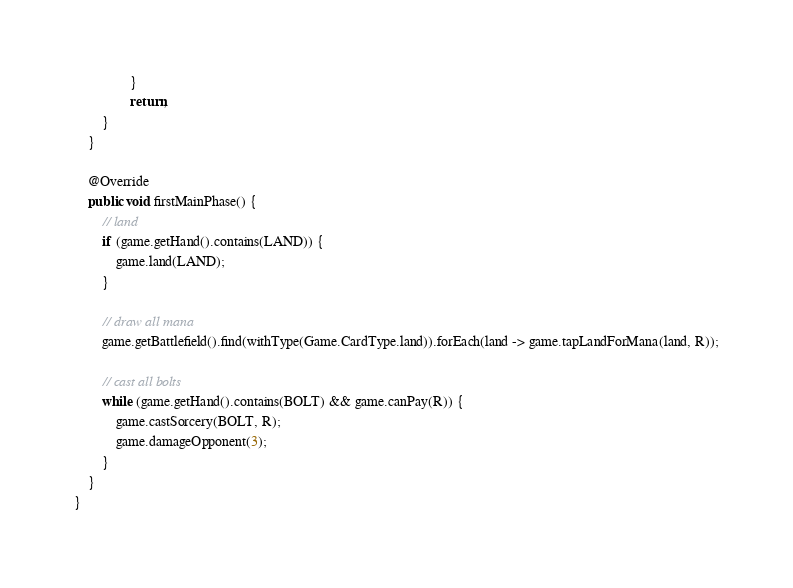<code> <loc_0><loc_0><loc_500><loc_500><_Java_>                }
                return;
        }
    }

    @Override
    public void firstMainPhase() {
        // land
        if (game.getHand().contains(LAND)) {
            game.land(LAND);
        }

        // draw all mana
        game.getBattlefield().find(withType(Game.CardType.land)).forEach(land -> game.tapLandForMana(land, R));

        // cast all bolts
        while (game.getHand().contains(BOLT) && game.canPay(R)) {
            game.castSorcery(BOLT, R);
            game.damageOpponent(3);
        }
    }
}
</code> 